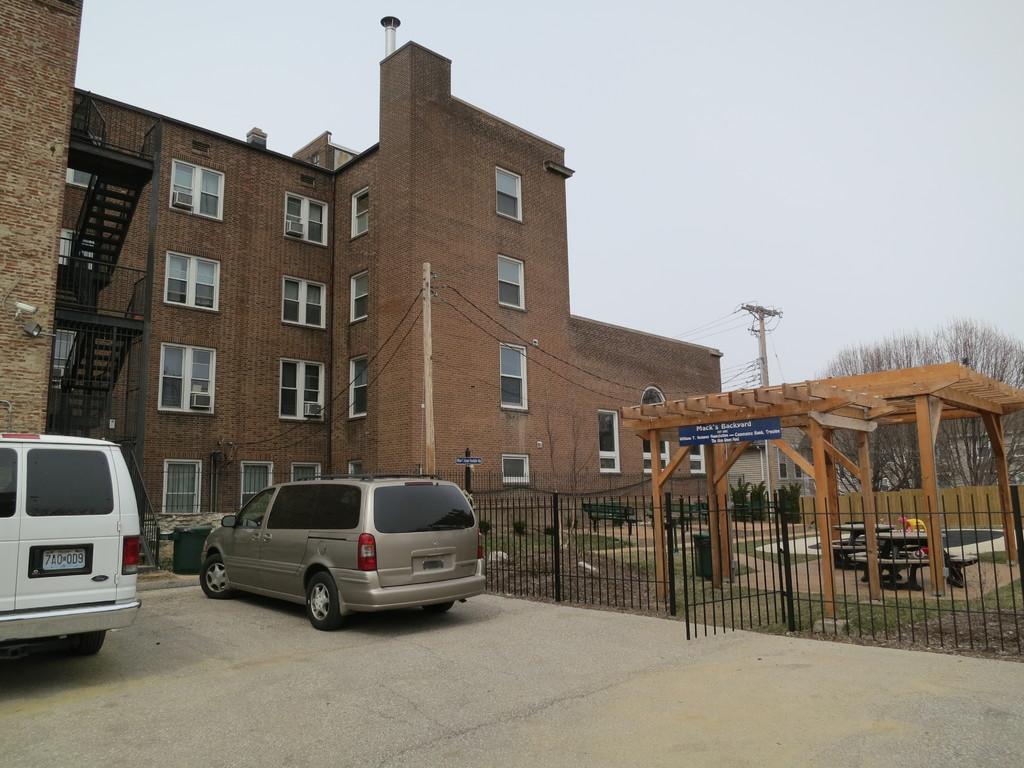Describe this image in one or two sentences. In this image we can see one big building, three staircases, one antenna with so many wires, so many windows, some objects on the windows, one gate, two fences, two cars parked on the road, in front of the building. Some objects are on the surface, two dustbins, tables with chairs and at the top there is the sky. There are so many trees, plants, bushes and grass on the ground. 